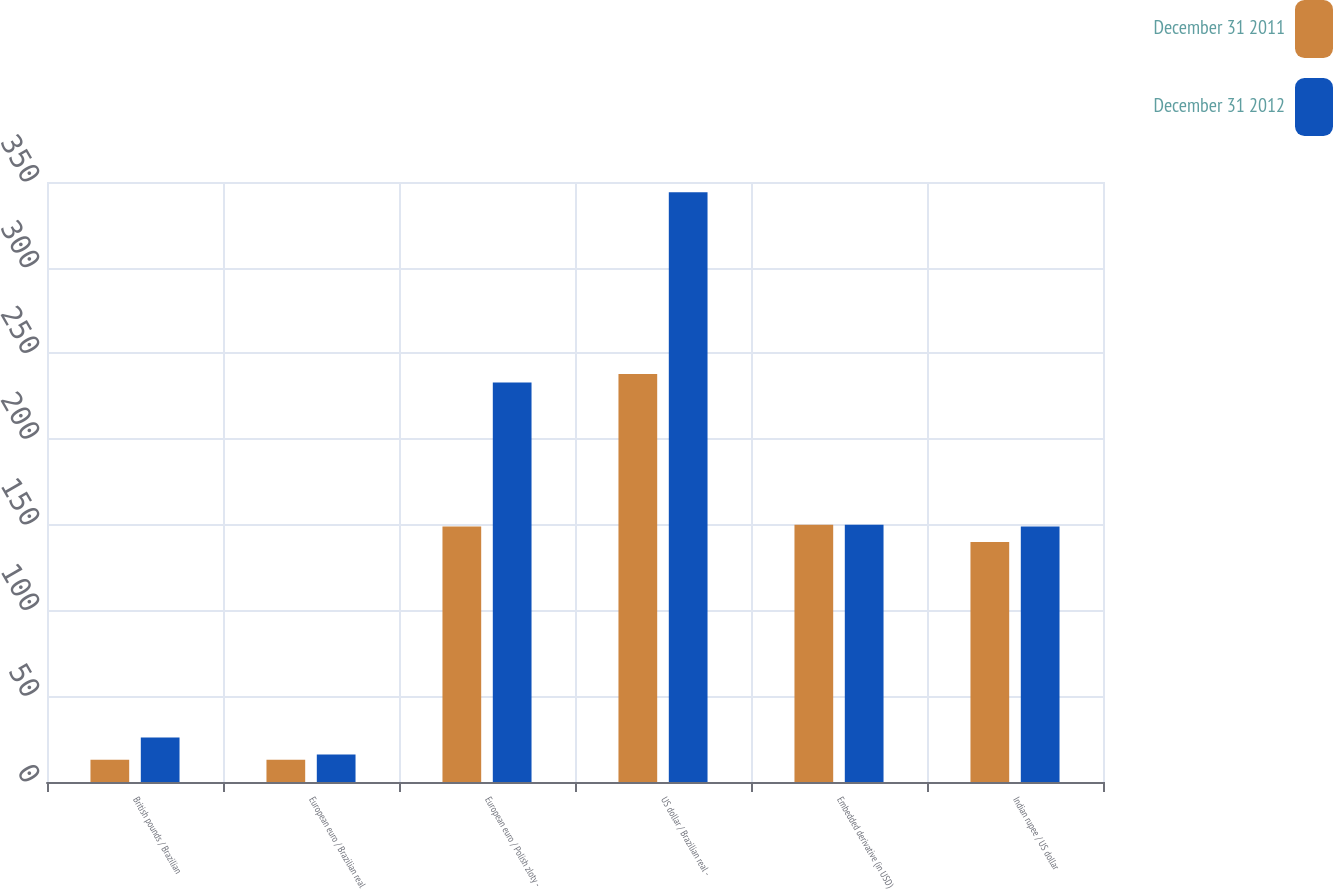<chart> <loc_0><loc_0><loc_500><loc_500><stacked_bar_chart><ecel><fcel>British pounds / Brazilian<fcel>European euro / Brazilian real<fcel>European euro / Polish zloty -<fcel>US dollar / Brazilian real -<fcel>Embedded derivative (in USD)<fcel>Indian rupee / US dollar<nl><fcel>December 31 2011<fcel>13<fcel>13<fcel>149<fcel>238<fcel>150<fcel>140<nl><fcel>December 31 2012<fcel>26<fcel>16<fcel>233<fcel>344<fcel>150<fcel>149<nl></chart> 